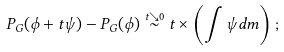Convert formula to latex. <formula><loc_0><loc_0><loc_500><loc_500>P _ { G } ( \phi + t \psi ) - P _ { G } ( \phi ) \stackrel { t \searrow 0 } { \sim } t \times \left ( \int \psi d m \right ) ;</formula> 